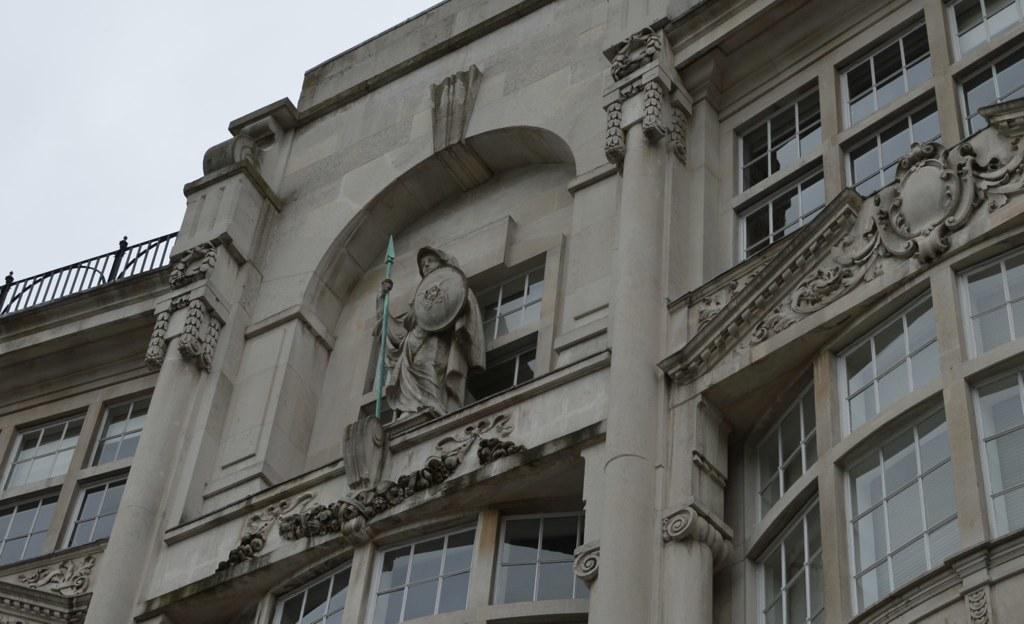Can you describe this image briefly? In this image, we can see a building. There is a sculpture in the middle of the image. In the top left of the image, we can see the sky. 